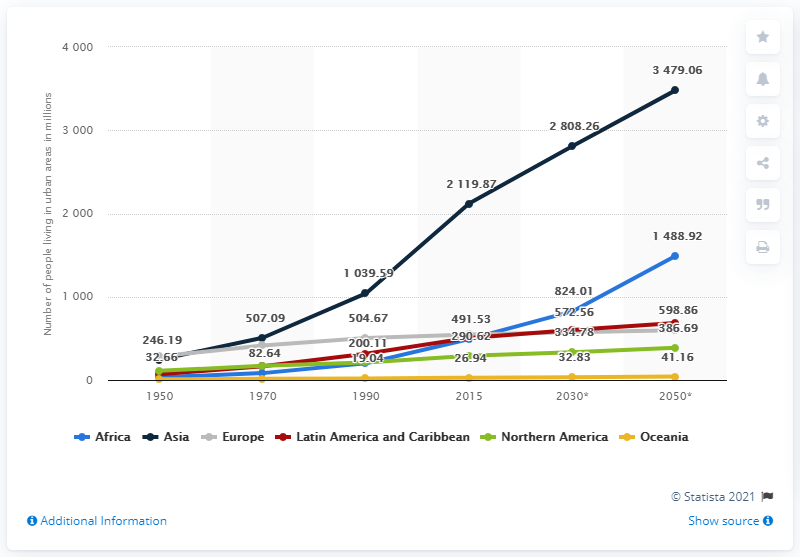Outline some significant characteristics in this image. In the year 1990, the region with the largest population living in urban areas was Asia. The maximum urban population in Asia is 34,464, while the minimum urban population in Europe is 10,946. By the year 2050, it is projected that a significant number of people in Africa will be living in urban areas. 